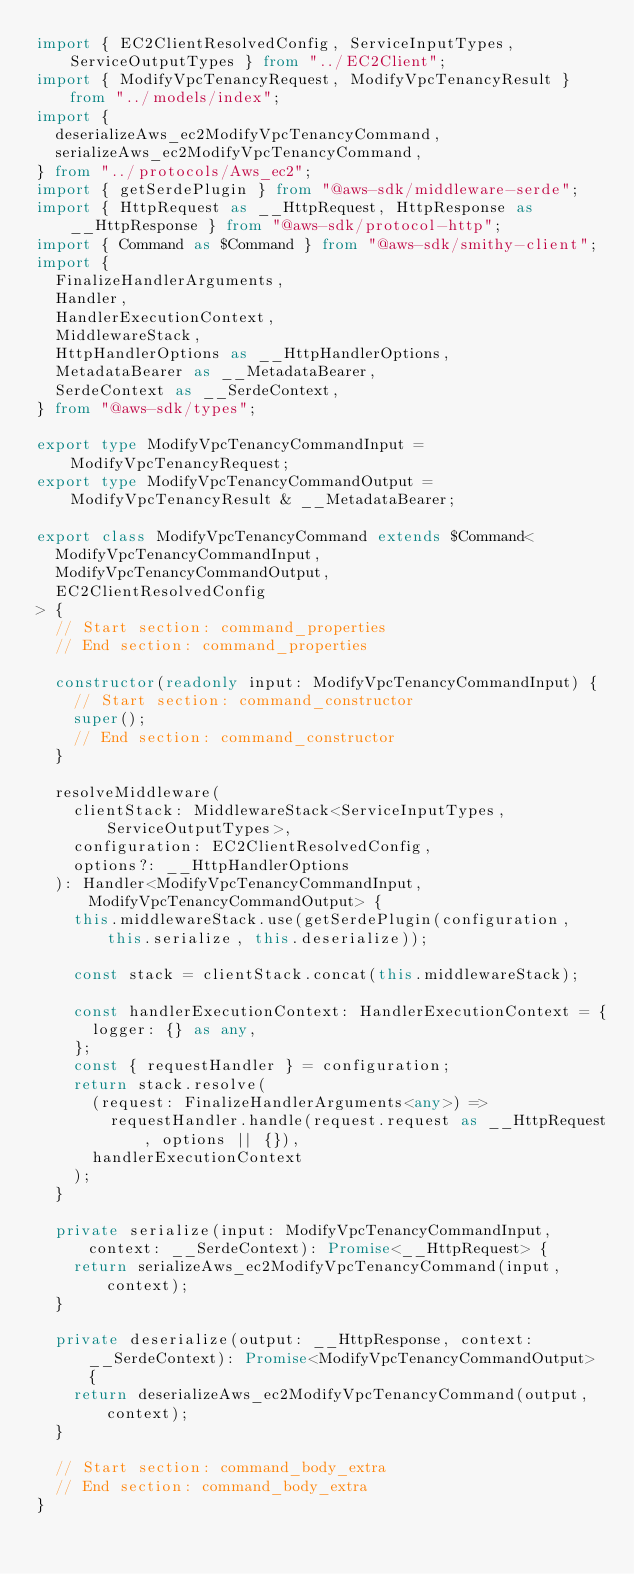<code> <loc_0><loc_0><loc_500><loc_500><_TypeScript_>import { EC2ClientResolvedConfig, ServiceInputTypes, ServiceOutputTypes } from "../EC2Client";
import { ModifyVpcTenancyRequest, ModifyVpcTenancyResult } from "../models/index";
import {
  deserializeAws_ec2ModifyVpcTenancyCommand,
  serializeAws_ec2ModifyVpcTenancyCommand,
} from "../protocols/Aws_ec2";
import { getSerdePlugin } from "@aws-sdk/middleware-serde";
import { HttpRequest as __HttpRequest, HttpResponse as __HttpResponse } from "@aws-sdk/protocol-http";
import { Command as $Command } from "@aws-sdk/smithy-client";
import {
  FinalizeHandlerArguments,
  Handler,
  HandlerExecutionContext,
  MiddlewareStack,
  HttpHandlerOptions as __HttpHandlerOptions,
  MetadataBearer as __MetadataBearer,
  SerdeContext as __SerdeContext,
} from "@aws-sdk/types";

export type ModifyVpcTenancyCommandInput = ModifyVpcTenancyRequest;
export type ModifyVpcTenancyCommandOutput = ModifyVpcTenancyResult & __MetadataBearer;

export class ModifyVpcTenancyCommand extends $Command<
  ModifyVpcTenancyCommandInput,
  ModifyVpcTenancyCommandOutput,
  EC2ClientResolvedConfig
> {
  // Start section: command_properties
  // End section: command_properties

  constructor(readonly input: ModifyVpcTenancyCommandInput) {
    // Start section: command_constructor
    super();
    // End section: command_constructor
  }

  resolveMiddleware(
    clientStack: MiddlewareStack<ServiceInputTypes, ServiceOutputTypes>,
    configuration: EC2ClientResolvedConfig,
    options?: __HttpHandlerOptions
  ): Handler<ModifyVpcTenancyCommandInput, ModifyVpcTenancyCommandOutput> {
    this.middlewareStack.use(getSerdePlugin(configuration, this.serialize, this.deserialize));

    const stack = clientStack.concat(this.middlewareStack);

    const handlerExecutionContext: HandlerExecutionContext = {
      logger: {} as any,
    };
    const { requestHandler } = configuration;
    return stack.resolve(
      (request: FinalizeHandlerArguments<any>) =>
        requestHandler.handle(request.request as __HttpRequest, options || {}),
      handlerExecutionContext
    );
  }

  private serialize(input: ModifyVpcTenancyCommandInput, context: __SerdeContext): Promise<__HttpRequest> {
    return serializeAws_ec2ModifyVpcTenancyCommand(input, context);
  }

  private deserialize(output: __HttpResponse, context: __SerdeContext): Promise<ModifyVpcTenancyCommandOutput> {
    return deserializeAws_ec2ModifyVpcTenancyCommand(output, context);
  }

  // Start section: command_body_extra
  // End section: command_body_extra
}
</code> 